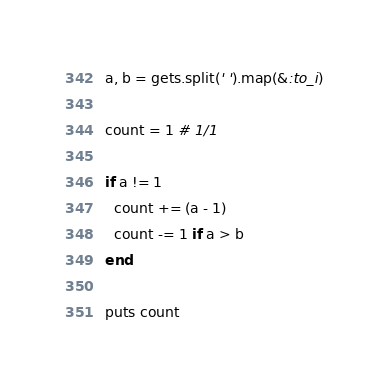Convert code to text. <code><loc_0><loc_0><loc_500><loc_500><_Ruby_>a, b = gets.split(' ').map(&:to_i)

count = 1 # 1/1

if a != 1
  count += (a - 1)
  count -= 1 if a > b
end

puts count
</code> 